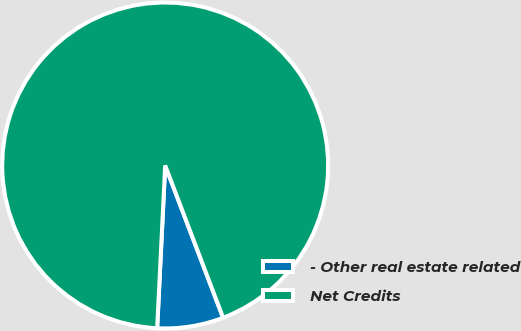<chart> <loc_0><loc_0><loc_500><loc_500><pie_chart><fcel>- Other real estate related<fcel>Net Credits<nl><fcel>6.57%<fcel>93.43%<nl></chart> 